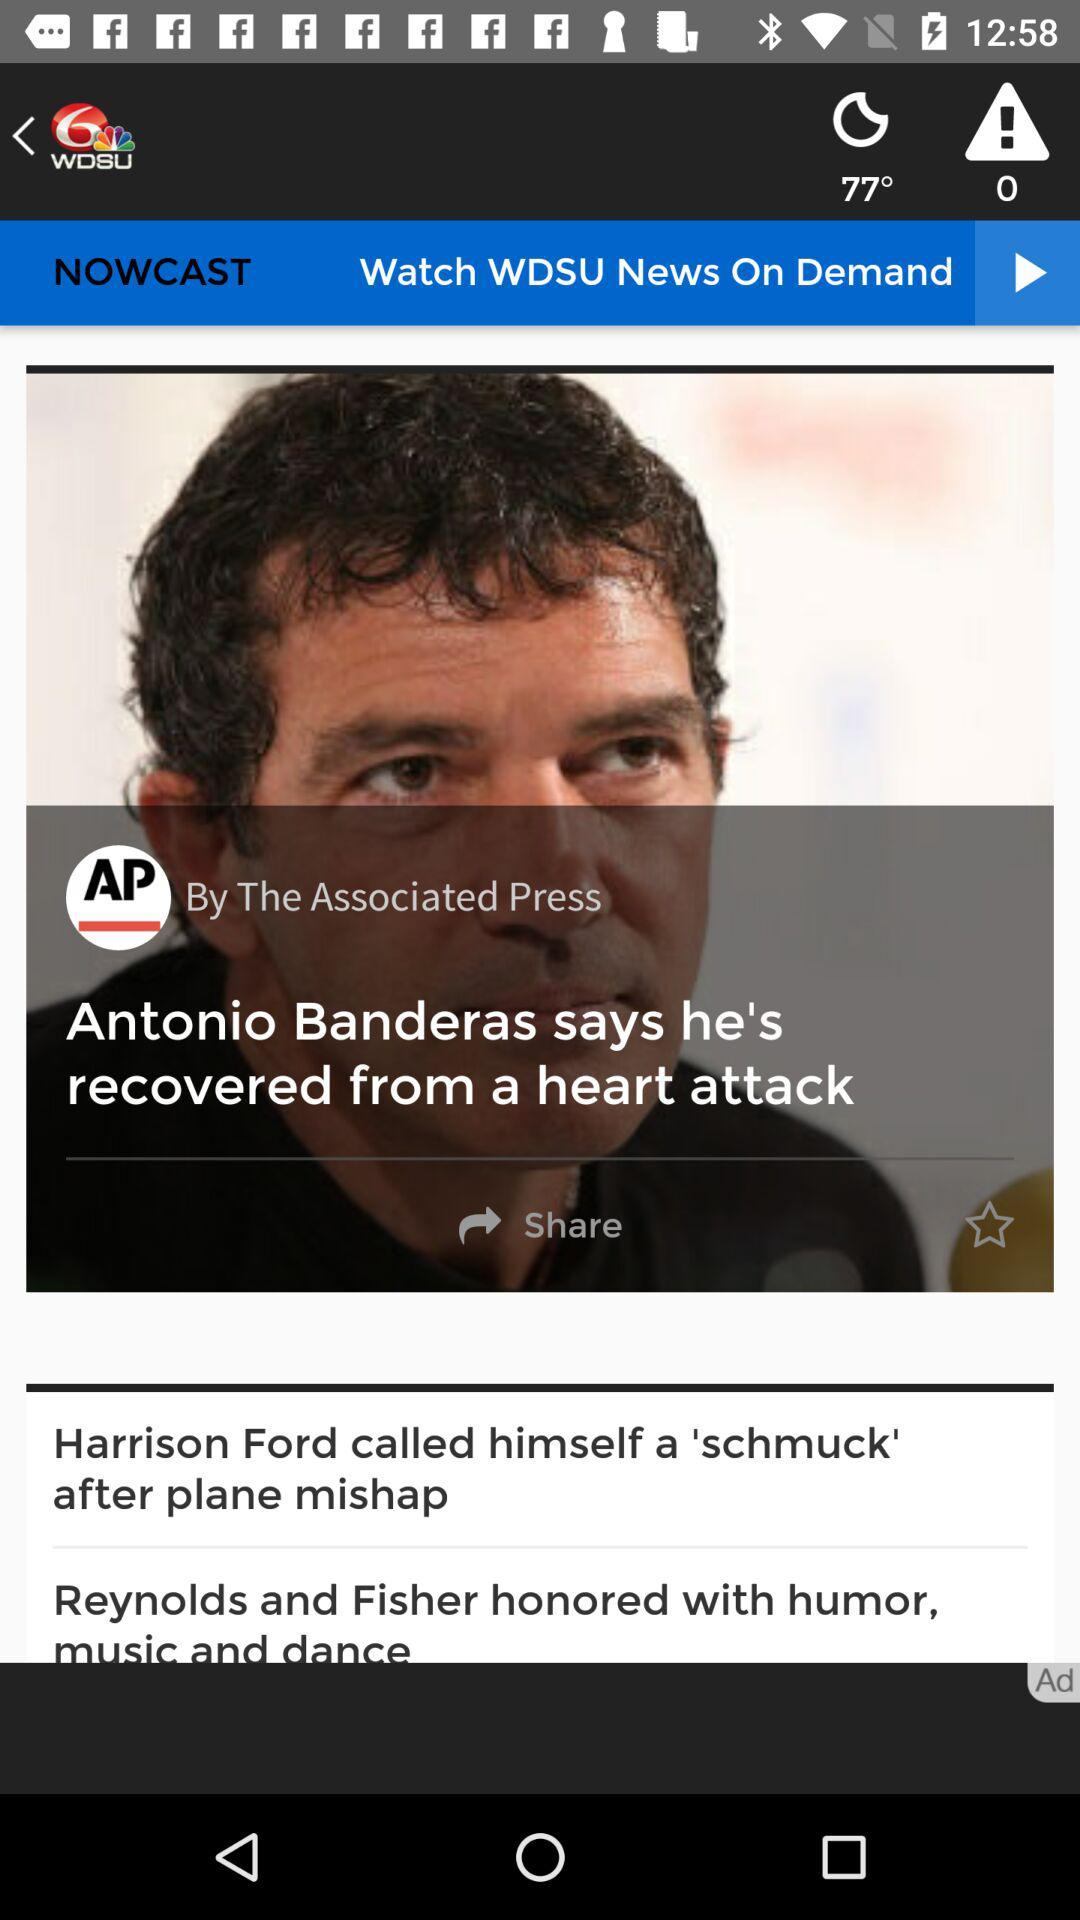What is the weather forecast? The weather is clear. 